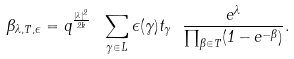<formula> <loc_0><loc_0><loc_500><loc_500>\Theta _ { \lambda , T , \epsilon } = q ^ { \frac { | \lambda | ^ { 2 } } { 2 k } } \ \sum _ { \gamma \in L } \epsilon ( \gamma ) t _ { \gamma } \ \frac { e ^ { \lambda } } { \prod _ { \beta \in T } ( 1 - e ^ { - \beta } ) } .</formula> 